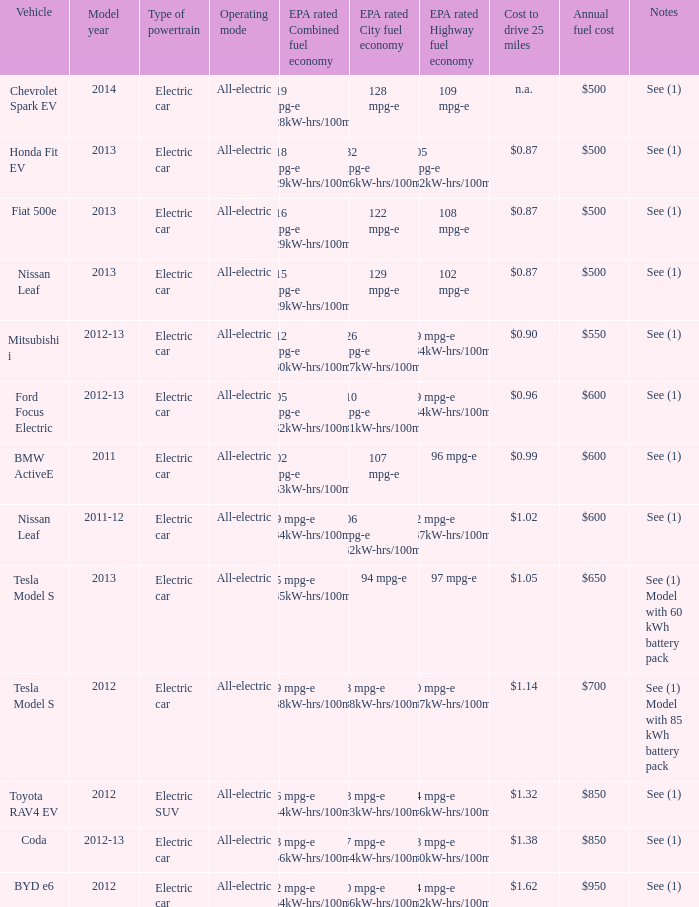What is the epa highway fuel economy for an electric suv? 74 mpg-e (46kW-hrs/100mi). 